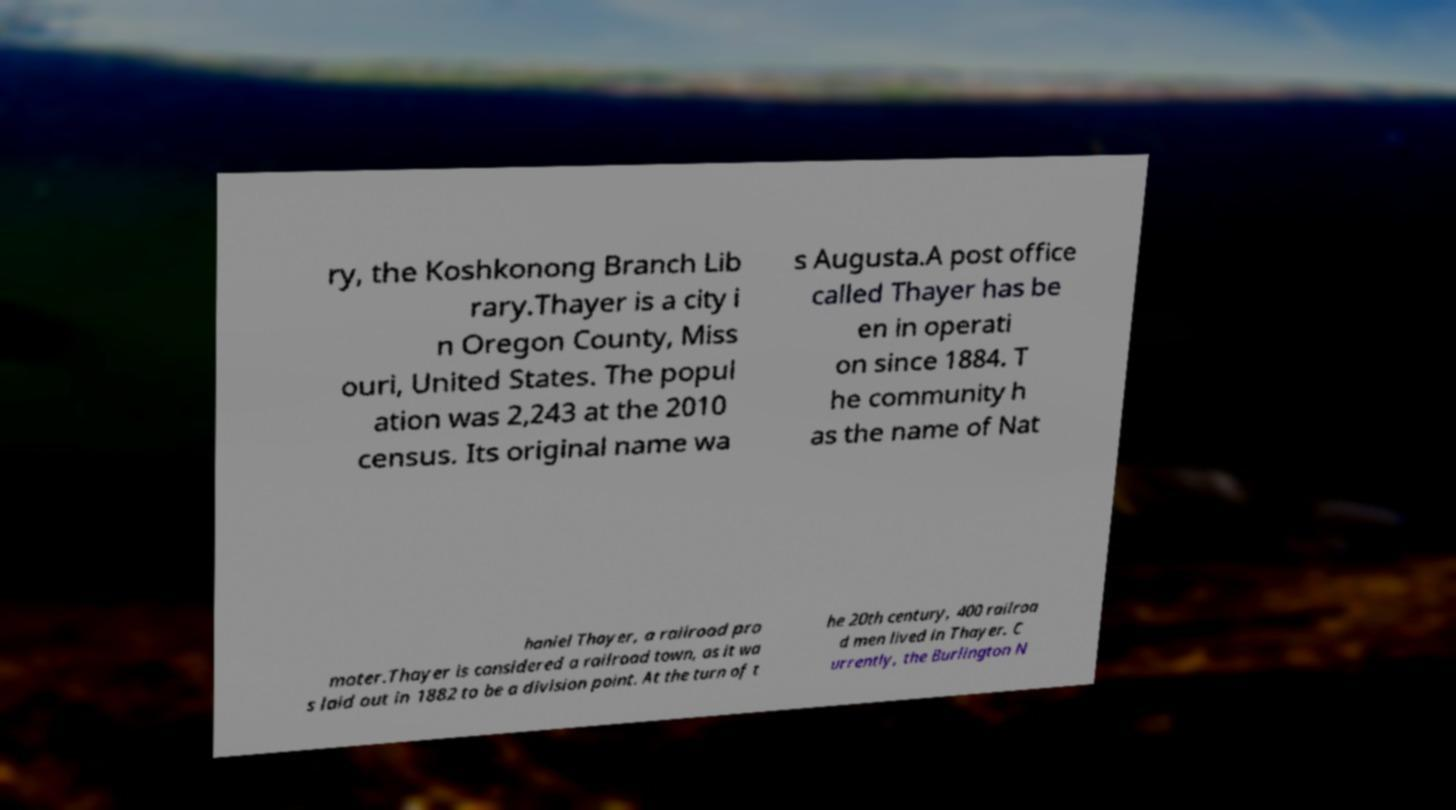What messages or text are displayed in this image? I need them in a readable, typed format. ry, the Koshkonong Branch Lib rary.Thayer is a city i n Oregon County, Miss ouri, United States. The popul ation was 2,243 at the 2010 census. Its original name wa s Augusta.A post office called Thayer has be en in operati on since 1884. T he community h as the name of Nat haniel Thayer, a railroad pro moter.Thayer is considered a railroad town, as it wa s laid out in 1882 to be a division point. At the turn of t he 20th century, 400 railroa d men lived in Thayer. C urrently, the Burlington N 